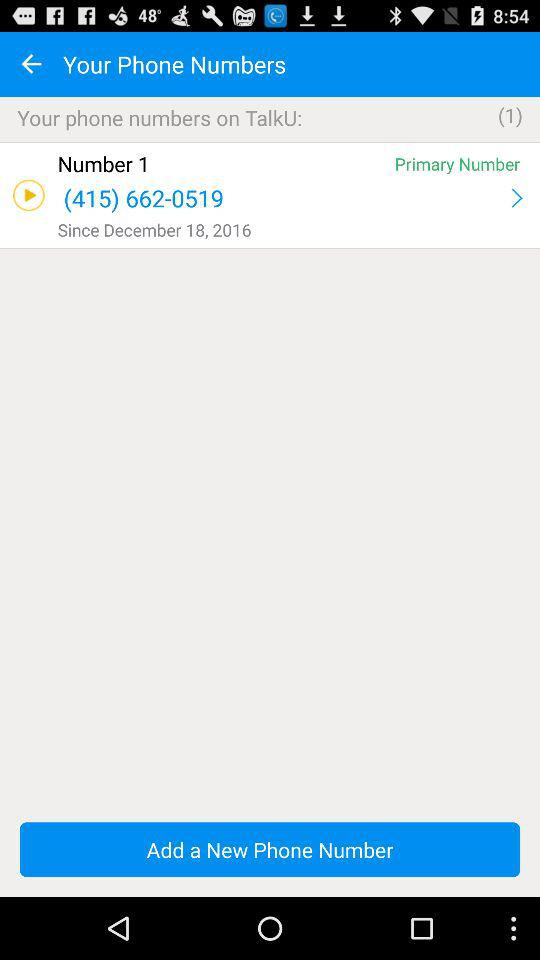In what category is the phone number saved? The category is "Primary Number". 